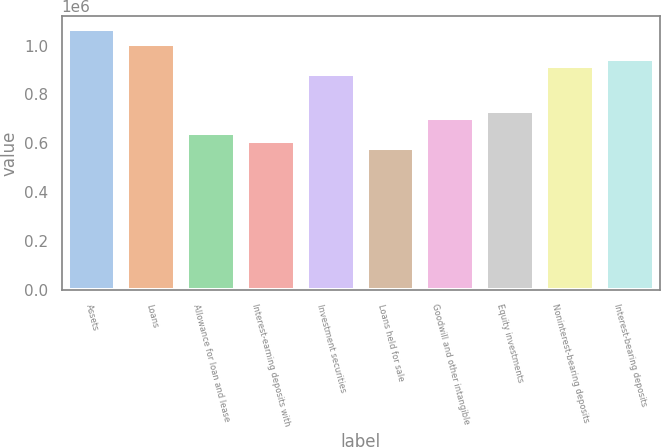Convert chart to OTSL. <chart><loc_0><loc_0><loc_500><loc_500><bar_chart><fcel>Assets<fcel>Loans<fcel>Allowance for loan and lease<fcel>Interest-earning deposits with<fcel>Investment securities<fcel>Loans held for sale<fcel>Goodwill and other intangible<fcel>Equity investments<fcel>Noninterest-bearing deposits<fcel>Interest-bearing deposits<nl><fcel>1.06787e+06<fcel>1.00685e+06<fcel>640724<fcel>610213<fcel>884808<fcel>579702<fcel>701745<fcel>732255<fcel>915319<fcel>945830<nl></chart> 